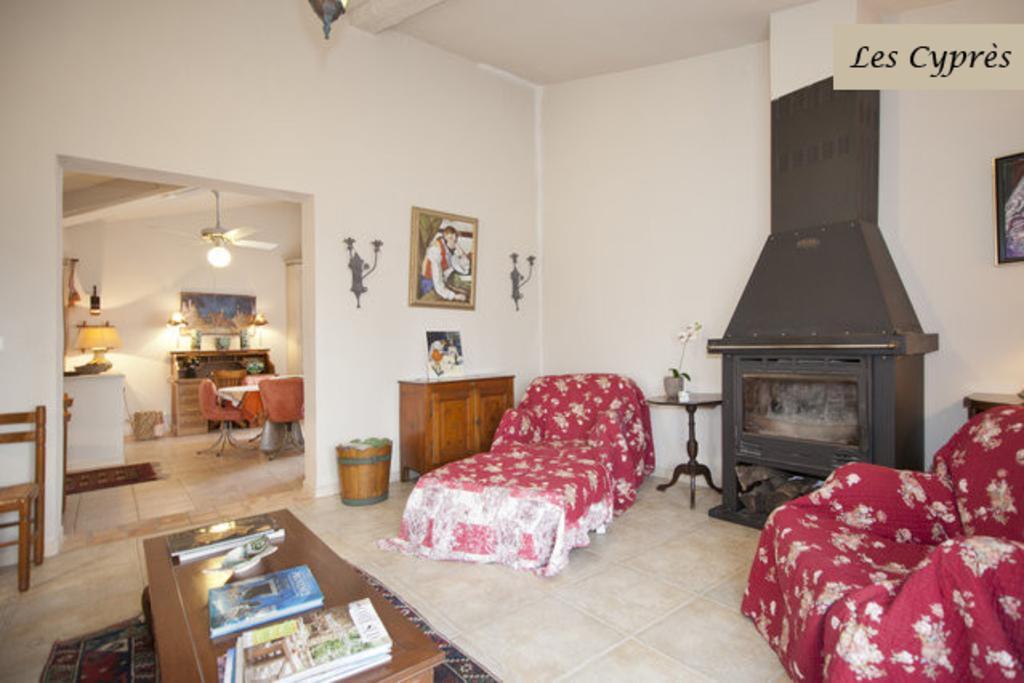Describe this image in one or two sentences. The image is inside the room. In the image on center there is a table on table we can see books,fan light,frames and a wall which is in white color. On right side there is a bed,couch another table on table there is a plant with flower pot,frames,basket and a wall which is in white color. On left side there is a chair and mat. 